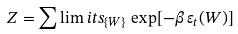<formula> <loc_0><loc_0><loc_500><loc_500>Z = \sum \lim i t s _ { \{ W \} } \, \exp [ - \beta \, \varepsilon _ { t } ( W ) ]</formula> 